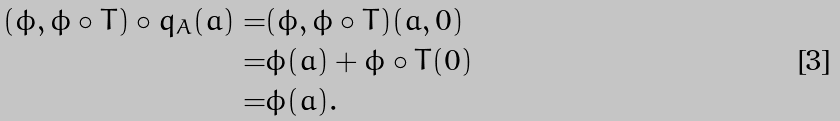<formula> <loc_0><loc_0><loc_500><loc_500>( \phi , \phi \circ T ) \circ q _ { A } ( a ) = & ( \phi , \phi \circ T ) ( a , 0 ) \\ = & \phi ( a ) + \phi \circ T ( 0 ) \\ = & \phi ( a ) .</formula> 